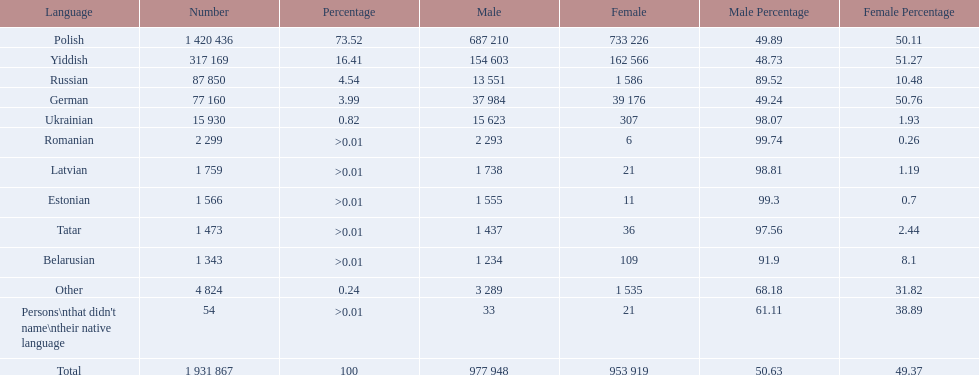How many languages are there? Polish, Yiddish, Russian, German, Ukrainian, Romanian, Latvian, Estonian, Tatar, Belarusian. Which language do more people speak? Polish. 